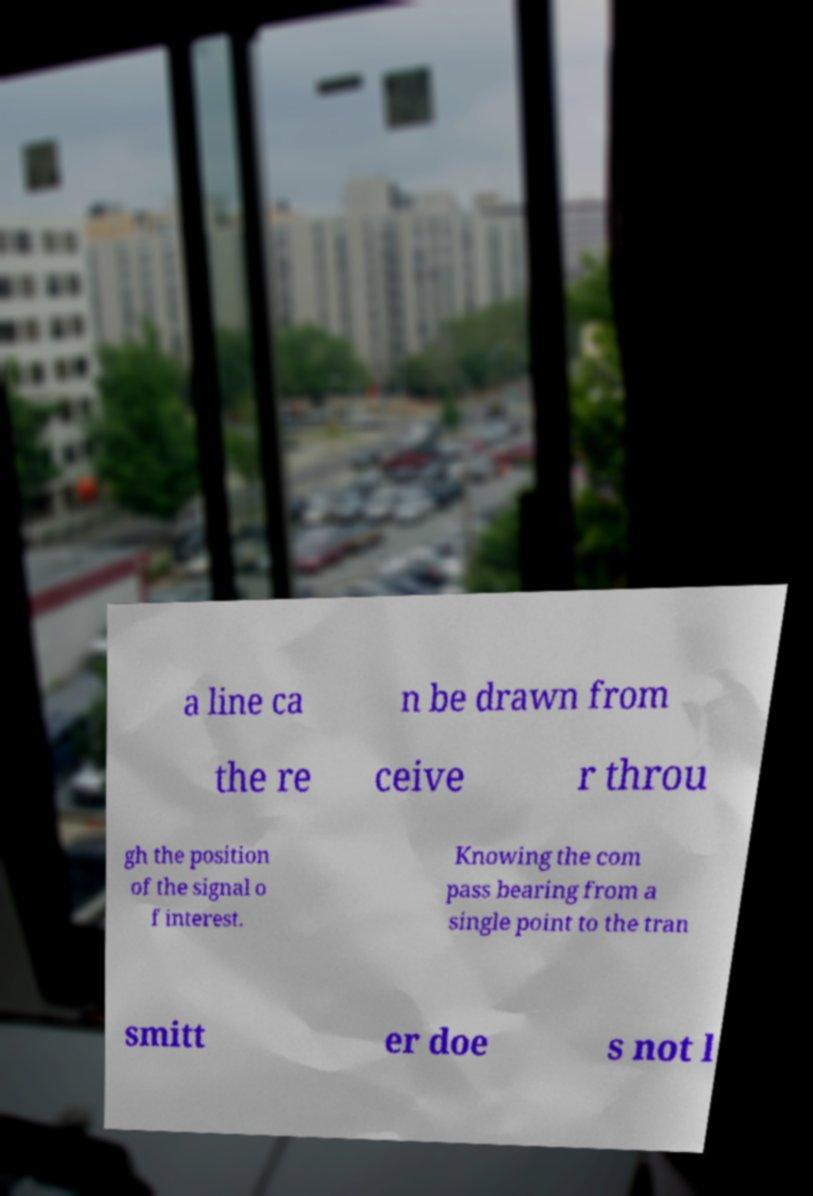Please read and relay the text visible in this image. What does it say? a line ca n be drawn from the re ceive r throu gh the position of the signal o f interest. Knowing the com pass bearing from a single point to the tran smitt er doe s not l 